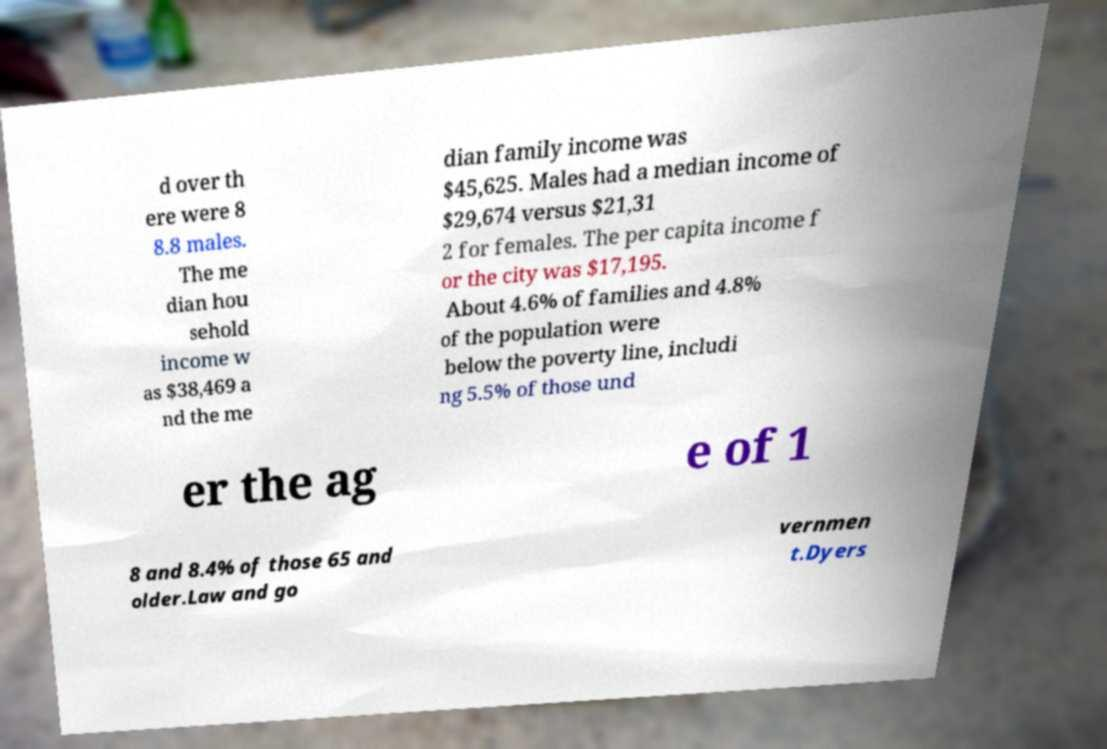For documentation purposes, I need the text within this image transcribed. Could you provide that? d over th ere were 8 8.8 males. The me dian hou sehold income w as $38,469 a nd the me dian family income was $45,625. Males had a median income of $29,674 versus $21,31 2 for females. The per capita income f or the city was $17,195. About 4.6% of families and 4.8% of the population were below the poverty line, includi ng 5.5% of those und er the ag e of 1 8 and 8.4% of those 65 and older.Law and go vernmen t.Dyers 